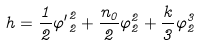Convert formula to latex. <formula><loc_0><loc_0><loc_500><loc_500>h = \frac { 1 } { 2 } { { \varphi ^ { \prime } } _ { 2 } ^ { 2 } } + \frac { n _ { 0 } } { 2 } { \varphi } _ { 2 } ^ { 2 } + \frac { k } { 3 } { \varphi } _ { 2 } ^ { 3 }</formula> 